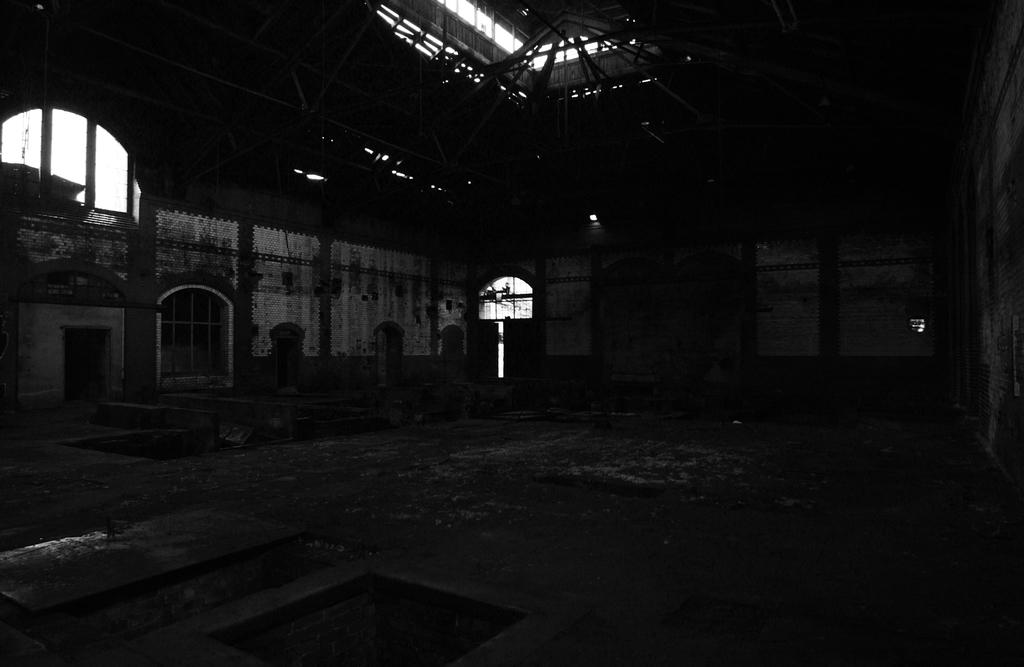What type of structures are visible in the image? There are walls in the image. What can be seen on the walls in the image? There are windows in the image. What is present on the ground in the image? There are objects on the ground in the image. How would you describe the lighting in the image? The image is dark. Can you see the eyes of the person taking a voyage in the image? There is no person or voyage present in the image. What time of day is it in the image, considering it's an afternoon scene? The image is described as dark, so it is not an afternoon scene. 